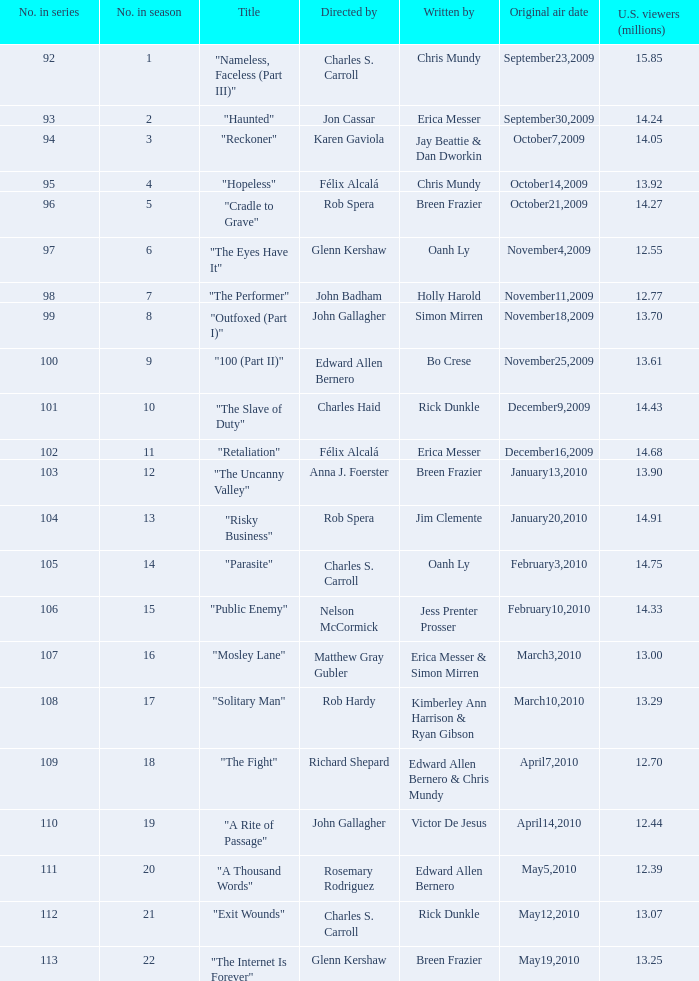On which date was the episode, with 13.92 million us viewers, initially broadcasted? October14,2009. 